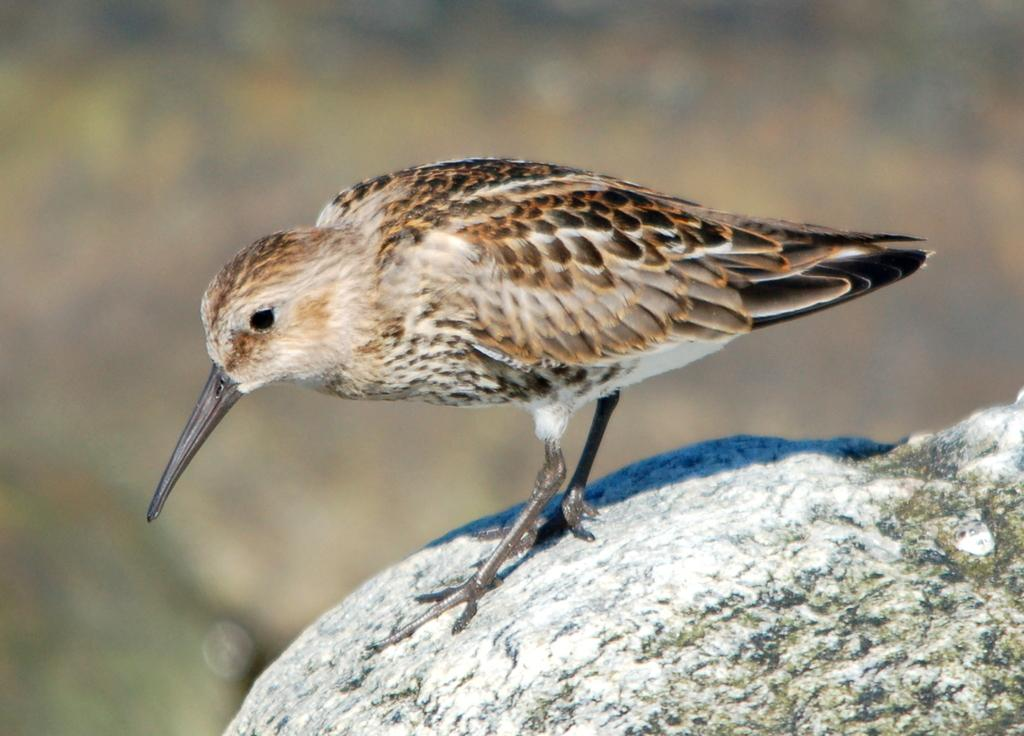What type of animal can be seen in the picture? There is a bird in the picture. Where is the bird located in the image? The bird is standing on a rock. Can you describe the background of the image? The background of the image is blurred. What type of blade is the bird using to cut the bell in the image? There is no blade, bell, or any cutting activity present in the image. The bird is simply standing on a rock with a blurred background. 